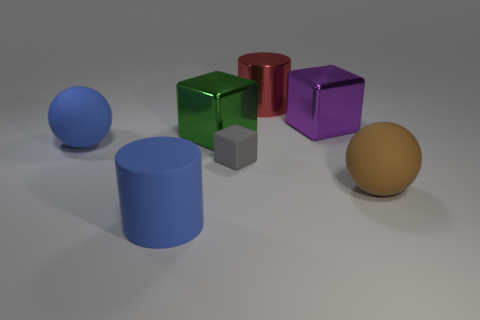There is a matte ball on the left side of the green metallic object; is its size the same as the tiny gray block?
Your answer should be very brief. No. How many other things are the same size as the purple object?
Ensure brevity in your answer.  5. What is the color of the tiny matte block?
Your response must be concise. Gray. What material is the ball that is to the right of the matte cylinder?
Your response must be concise. Rubber. Is the number of brown things behind the matte block the same as the number of big blue matte spheres?
Make the answer very short. No. Is the brown rubber object the same shape as the large purple thing?
Provide a succinct answer. No. Are there any other things that are the same color as the tiny matte object?
Your answer should be compact. No. What shape is the matte thing that is to the left of the matte block and behind the large brown thing?
Give a very brief answer. Sphere. Are there an equal number of large blue rubber objects that are behind the big red cylinder and tiny objects that are on the left side of the big matte cylinder?
Provide a short and direct response. Yes. How many spheres are either rubber objects or tiny gray matte things?
Your answer should be compact. 2. 